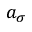Convert formula to latex. <formula><loc_0><loc_0><loc_500><loc_500>a _ { \sigma }</formula> 